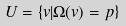Convert formula to latex. <formula><loc_0><loc_0><loc_500><loc_500>U = \{ v | \Omega ( v ) = p \}</formula> 